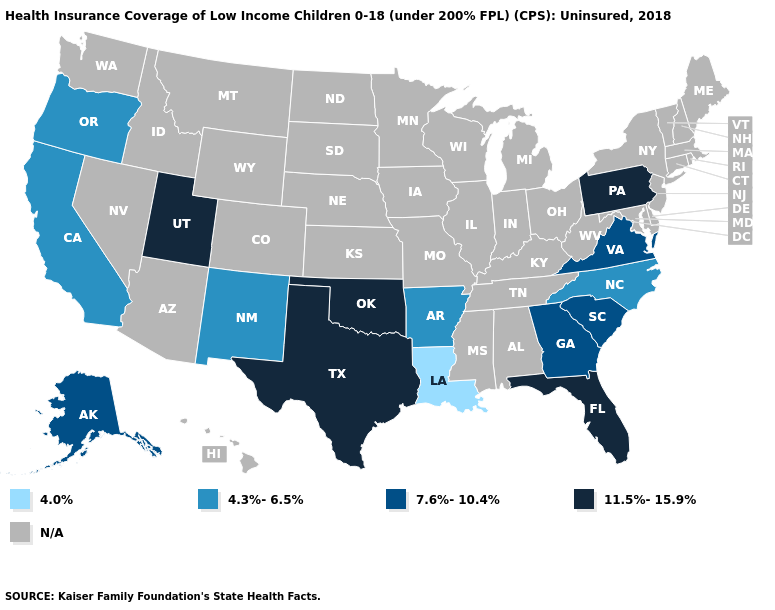Name the states that have a value in the range N/A?
Keep it brief. Alabama, Arizona, Colorado, Connecticut, Delaware, Hawaii, Idaho, Illinois, Indiana, Iowa, Kansas, Kentucky, Maine, Maryland, Massachusetts, Michigan, Minnesota, Mississippi, Missouri, Montana, Nebraska, Nevada, New Hampshire, New Jersey, New York, North Dakota, Ohio, Rhode Island, South Dakota, Tennessee, Vermont, Washington, West Virginia, Wisconsin, Wyoming. What is the highest value in the South ?
Keep it brief. 11.5%-15.9%. Name the states that have a value in the range 7.6%-10.4%?
Write a very short answer. Alaska, Georgia, South Carolina, Virginia. What is the value of Georgia?
Write a very short answer. 7.6%-10.4%. Which states have the lowest value in the USA?
Answer briefly. Louisiana. Name the states that have a value in the range 11.5%-15.9%?
Keep it brief. Florida, Oklahoma, Pennsylvania, Texas, Utah. What is the value of California?
Keep it brief. 4.3%-6.5%. Does North Carolina have the highest value in the USA?
Keep it brief. No. What is the value of Maine?
Short answer required. N/A. Name the states that have a value in the range 7.6%-10.4%?
Write a very short answer. Alaska, Georgia, South Carolina, Virginia. What is the value of Virginia?
Quick response, please. 7.6%-10.4%. Name the states that have a value in the range 7.6%-10.4%?
Quick response, please. Alaska, Georgia, South Carolina, Virginia. What is the value of South Dakota?
Quick response, please. N/A. 